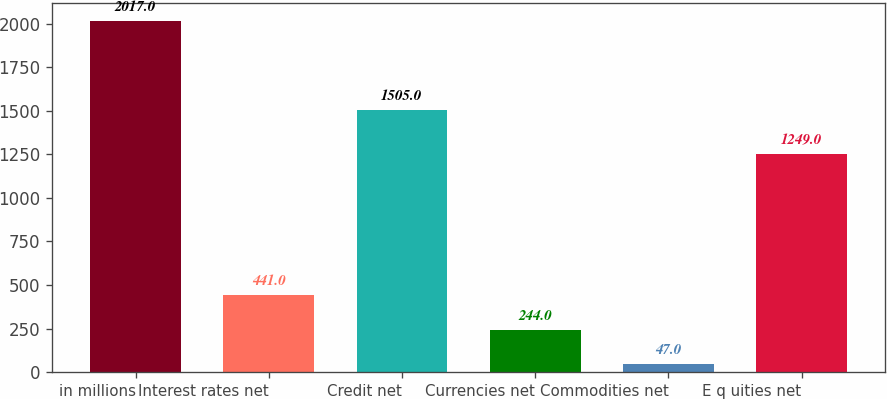Convert chart to OTSL. <chart><loc_0><loc_0><loc_500><loc_500><bar_chart><fcel>in millions<fcel>Interest rates net<fcel>Credit net<fcel>Currencies net<fcel>Commodities net<fcel>E q uities net<nl><fcel>2017<fcel>441<fcel>1505<fcel>244<fcel>47<fcel>1249<nl></chart> 